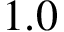Convert formula to latex. <formula><loc_0><loc_0><loc_500><loc_500>1 . 0</formula> 